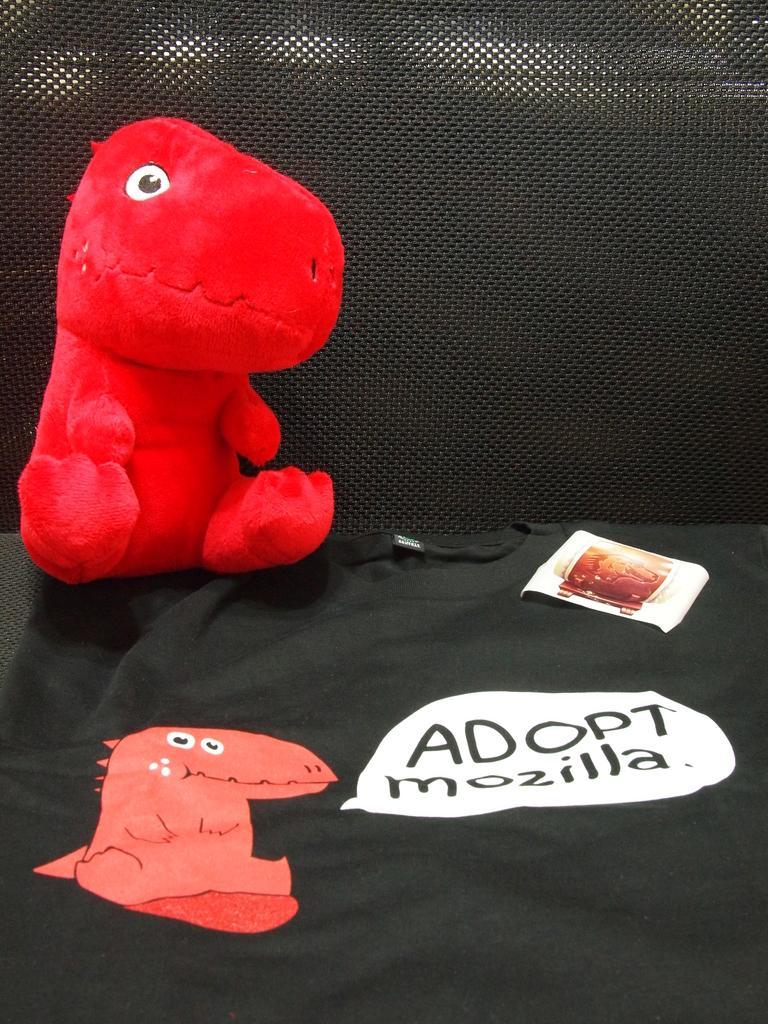Describe this image in one or two sentences. In this image we can see a toy in red color, beside here is the cartoon, and paper on it, the background is black. 